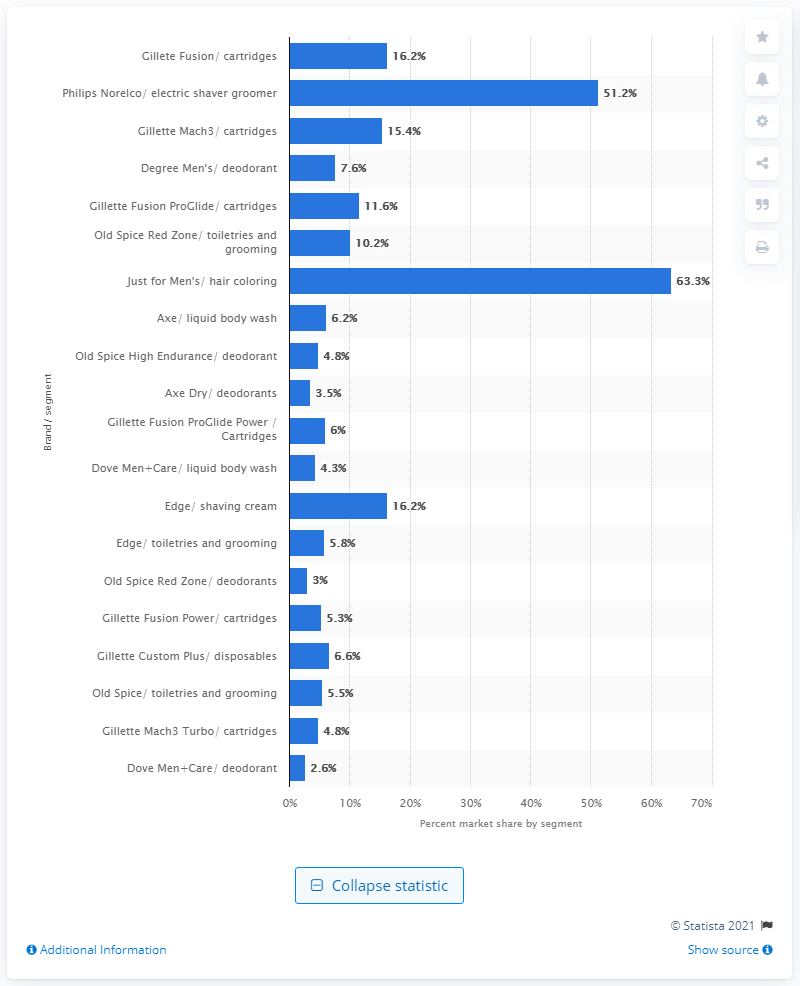Identify some key points in this picture. In 2014, Just for Men accounted for 63.3% of the men's hair coloring market. 